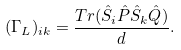<formula> <loc_0><loc_0><loc_500><loc_500>( { \Gamma } _ { L } ) _ { i k } = \frac { T r ( \hat { S } _ { i } \hat { P } \hat { S } _ { k } \hat { Q } ) } { d } .</formula> 